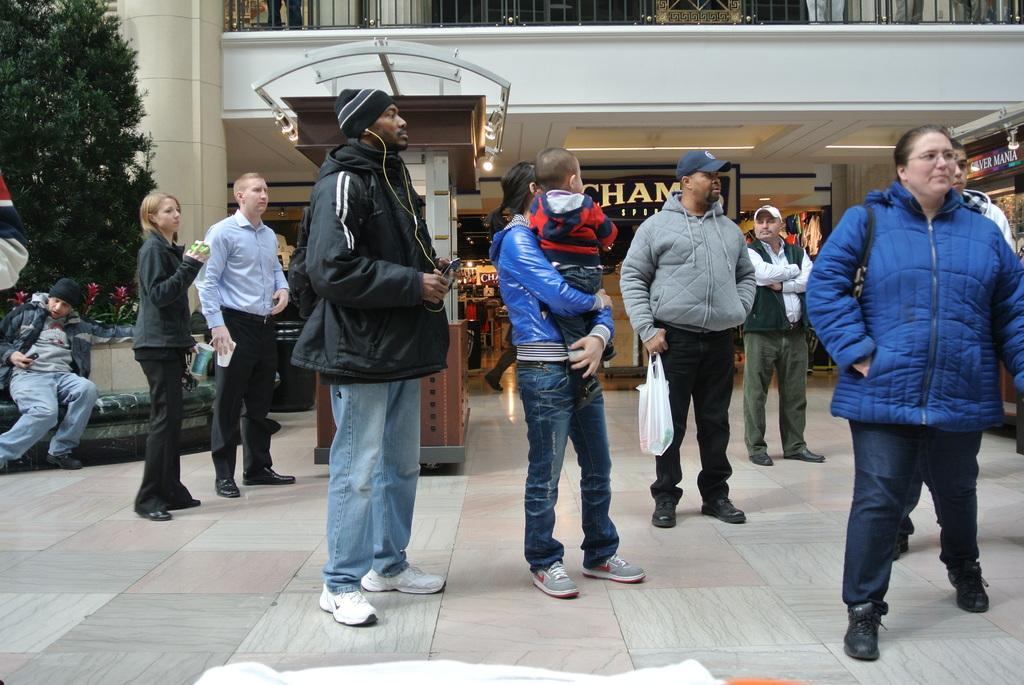Describe this image in one or two sentences. In this image I see number of people in which this person is sitting over here and I see the path. In the background I see the building and I see something is written over here and I see the lights and I see the leaves over here. 